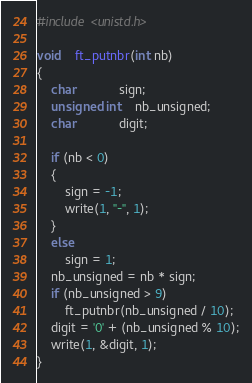<code> <loc_0><loc_0><loc_500><loc_500><_C_>#include <unistd.h>

void	ft_putnbr(int nb)
{
	char			sign;
	unsigned int	nb_unsigned;
	char			digit;

	if (nb < 0)
	{
		sign = -1;
		write(1, "-", 1);
	}
	else
		sign = 1;
	nb_unsigned = nb * sign;
	if (nb_unsigned > 9)
		ft_putnbr(nb_unsigned / 10);
	digit = '0' + (nb_unsigned % 10);
	write(1, &digit, 1);
}
</code> 